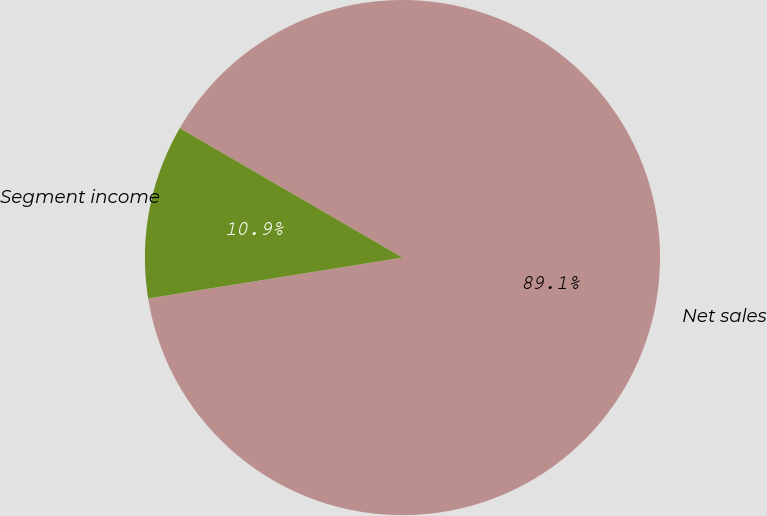Convert chart. <chart><loc_0><loc_0><loc_500><loc_500><pie_chart><fcel>Net sales<fcel>Segment income<nl><fcel>89.08%<fcel>10.92%<nl></chart> 